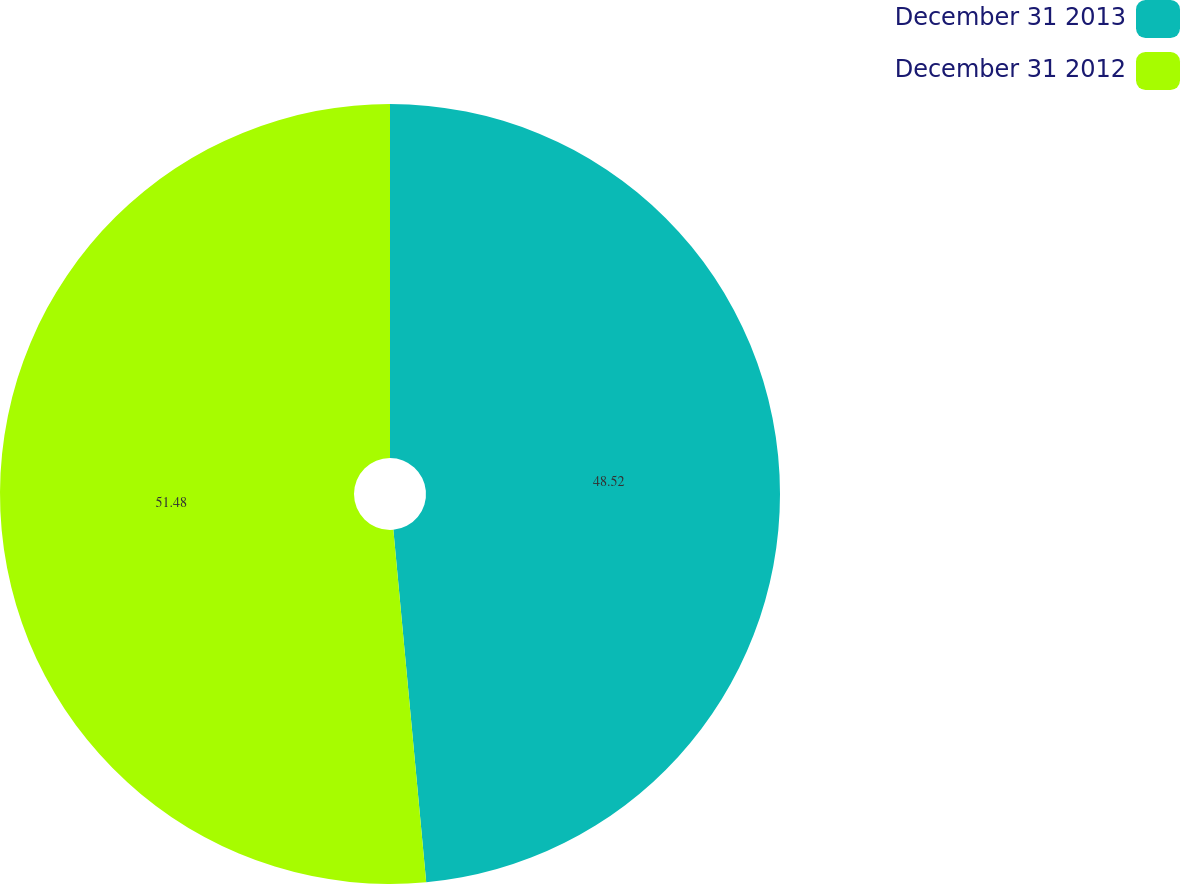Convert chart. <chart><loc_0><loc_0><loc_500><loc_500><pie_chart><fcel>December 31 2013<fcel>December 31 2012<nl><fcel>48.52%<fcel>51.48%<nl></chart> 